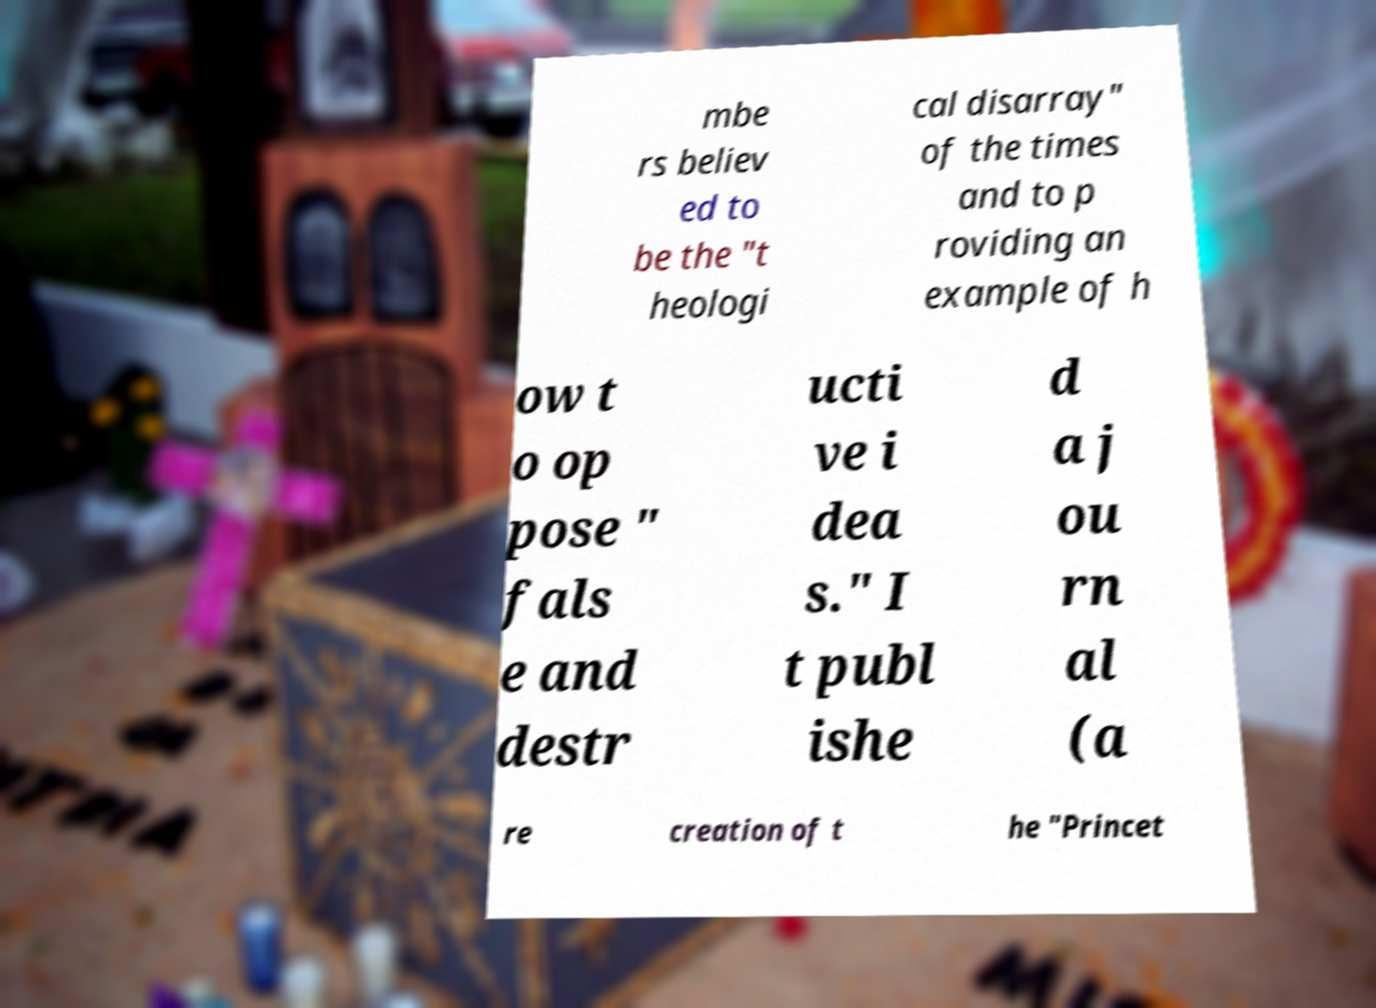Please read and relay the text visible in this image. What does it say? mbe rs believ ed to be the "t heologi cal disarray" of the times and to p roviding an example of h ow t o op pose " fals e and destr ucti ve i dea s." I t publ ishe d a j ou rn al (a re creation of t he "Princet 